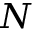<formula> <loc_0><loc_0><loc_500><loc_500>N</formula> 